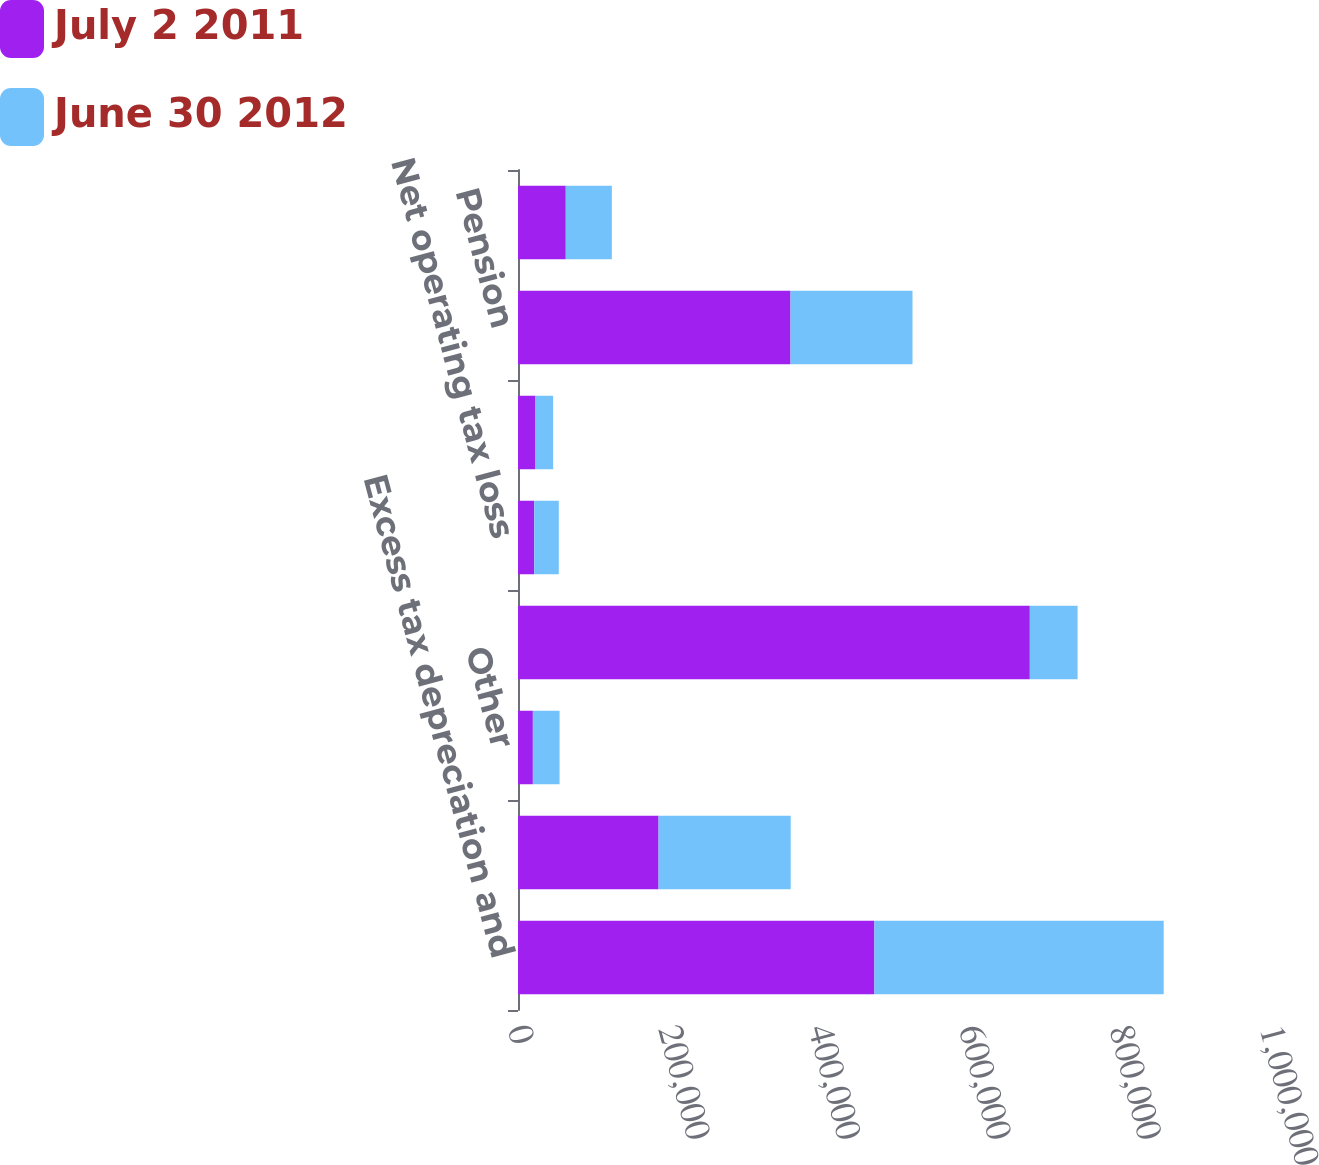Convert chart. <chart><loc_0><loc_0><loc_500><loc_500><stacked_bar_chart><ecel><fcel>Excess tax depreciation and<fcel>Goodwill and intangible assets<fcel>Other<fcel>Total deferred tax liabilities<fcel>Net operating tax loss<fcel>Benefit on unrecognized tax<fcel>Pension<fcel>Share-based compensation<nl><fcel>July 2 2011<fcel>473947<fcel>186921<fcel>19756<fcel>680624<fcel>21609<fcel>23287<fcel>362391<fcel>63522<nl><fcel>June 30 2012<fcel>384702<fcel>175747<fcel>35497<fcel>63522<fcel>32648<fcel>23463<fcel>162212<fcel>61273<nl></chart> 